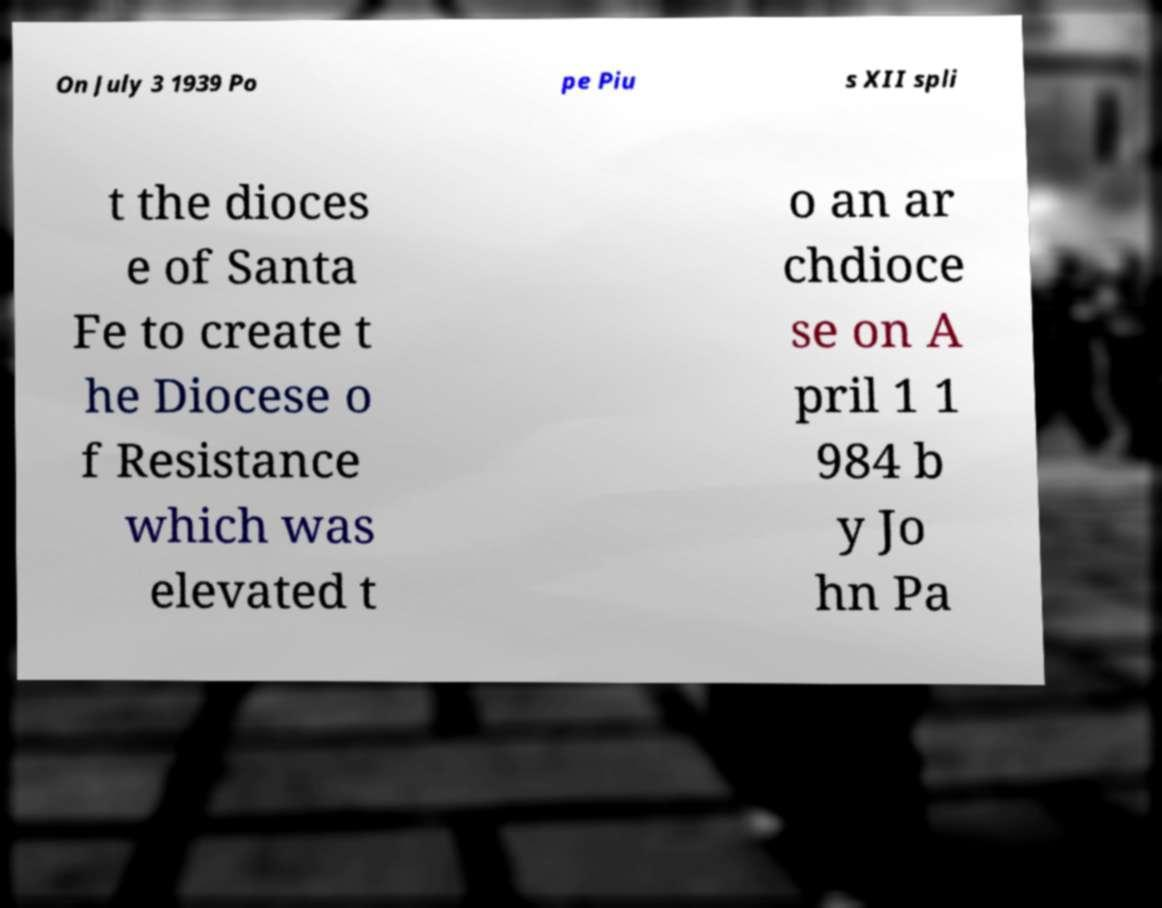What messages or text are displayed in this image? I need them in a readable, typed format. On July 3 1939 Po pe Piu s XII spli t the dioces e of Santa Fe to create t he Diocese o f Resistance which was elevated t o an ar chdioce se on A pril 1 1 984 b y Jo hn Pa 